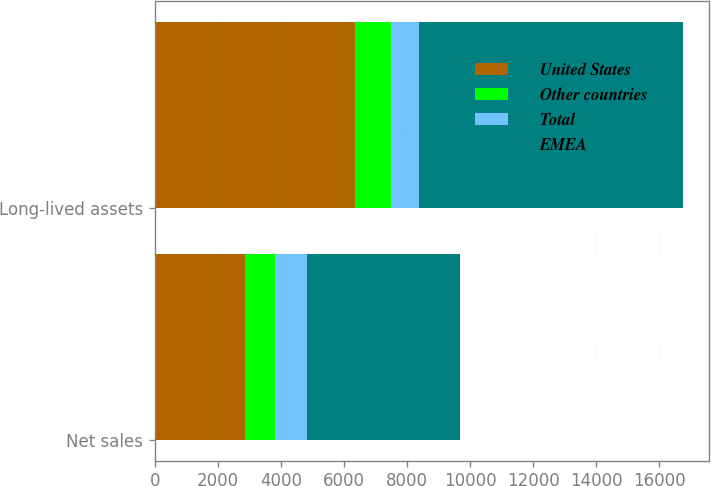Convert chart. <chart><loc_0><loc_0><loc_500><loc_500><stacked_bar_chart><ecel><fcel>Net sales<fcel>Long-lived assets<nl><fcel>United States<fcel>2859.6<fcel>6357.9<nl><fcel>Other countries<fcel>951.6<fcel>1129.1<nl><fcel>Total<fcel>1022.9<fcel>883.3<nl><fcel>EMEA<fcel>4834.1<fcel>8370.3<nl></chart> 